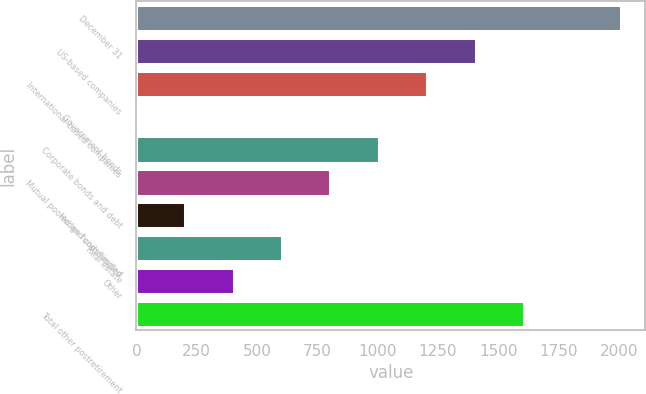<chart> <loc_0><loc_0><loc_500><loc_500><bar_chart><fcel>December 31<fcel>US-based companies<fcel>International-based companies<fcel>Government bonds<fcel>Corporate bonds and debt<fcel>Mutual pooled and commingled<fcel>Hedge funds/limited<fcel>Real estate<fcel>Other<fcel>Total other postretirement<nl><fcel>2010<fcel>1407.3<fcel>1206.4<fcel>1<fcel>1005.5<fcel>804.6<fcel>201.9<fcel>603.7<fcel>402.8<fcel>1608.2<nl></chart> 